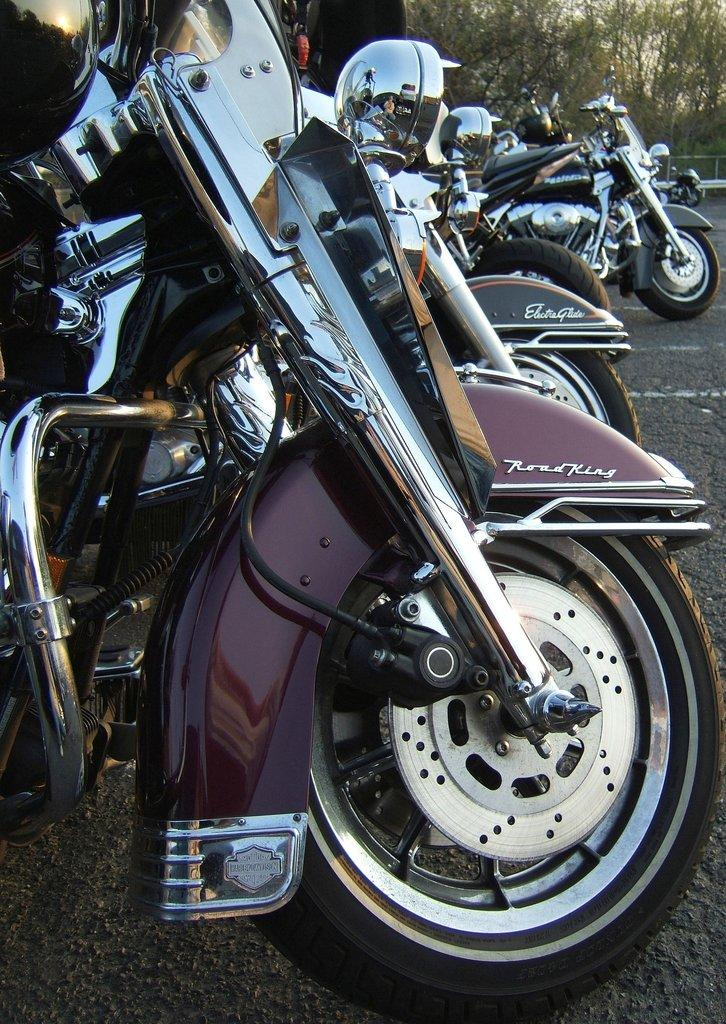What can be seen on the road in the image? There are bikes on the road in the image. What type of natural elements are visible in the background? There are trees in the background of the image. What else can be seen in the background of the image? There is an object in the background of the image. What is visible above the trees and object in the background? The sky is visible in the background of the image. How many lips can be seen on the bikes in the image? There are no lips present on the bikes or in the image. 